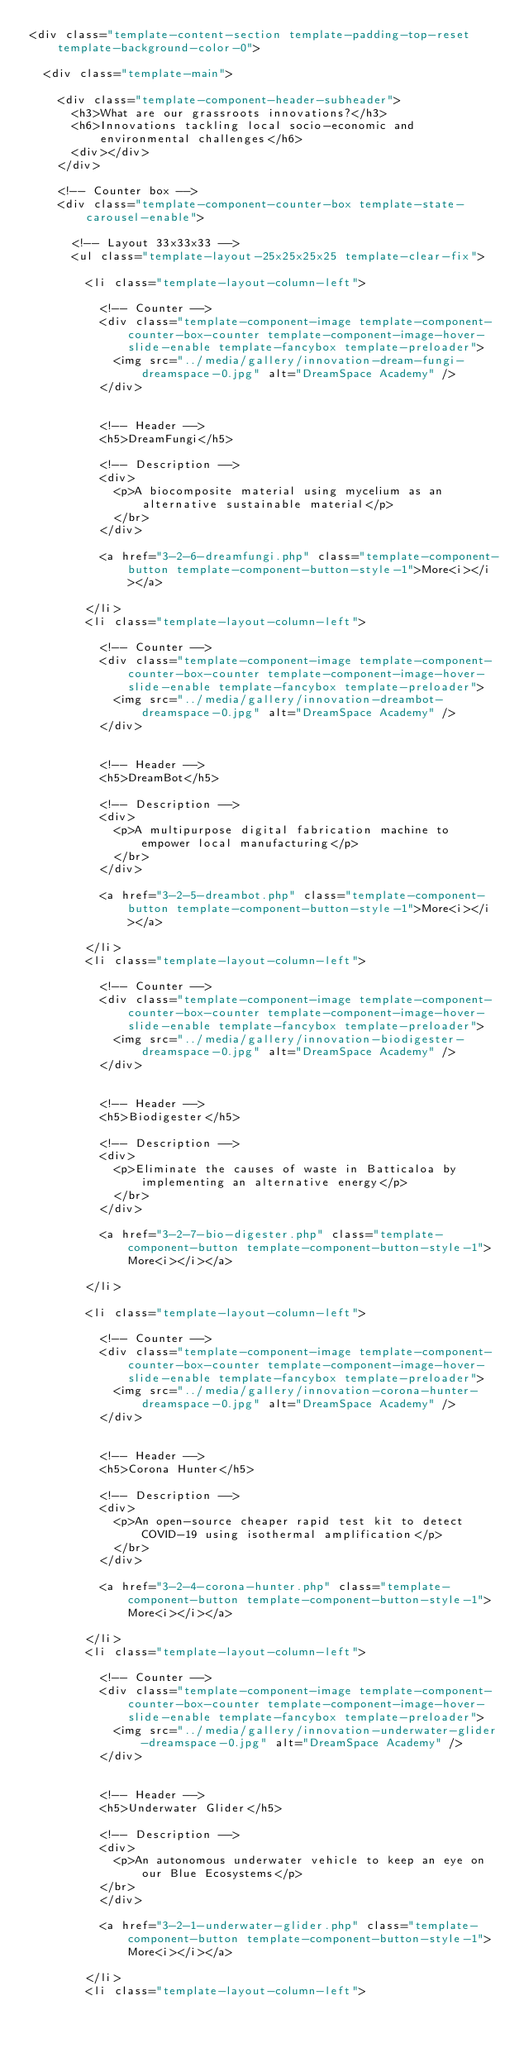Convert code to text. <code><loc_0><loc_0><loc_500><loc_500><_PHP_><div class="template-content-section template-padding-top-reset template-background-color-0">

	<div class="template-main">

		<div class="template-component-header-subheader">
			<h3>What are our grassroots innovations?</h3>
			<h6>Innovations tackling local socio-economic and environmental challenges</h6>
			<div></div>
		</div>

		<!-- Counter box -->
		<div class="template-component-counter-box template-state-carousel-enable">

			<!-- Layout 33x33x33 -->
			<ul class="template-layout-25x25x25x25 template-clear-fix">

				<li class="template-layout-column-left">

					<!-- Counter -->
					<div class="template-component-image template-component-counter-box-counter template-component-image-hover-slide-enable template-fancybox template-preloader">
						<img src="../media/gallery/innovation-dream-fungi-dreamspace-0.jpg" alt="DreamSpace Academy" />
					</div>


					<!-- Header -->
					<h5>DreamFungi</h5>

					<!-- Description -->
					<div>
						<p>A biocomposite material using mycelium as an alternative sustainable material</p>
						</br>
					</div>

					<a href="3-2-6-dreamfungi.php" class="template-component-button template-component-button-style-1">More<i></i></a>

				</li>
				<li class="template-layout-column-left">

					<!-- Counter -->
					<div class="template-component-image template-component-counter-box-counter template-component-image-hover-slide-enable template-fancybox template-preloader">
						<img src="../media/gallery/innovation-dreambot-dreamspace-0.jpg" alt="DreamSpace Academy" />
					</div>


					<!-- Header -->
					<h5>DreamBot</h5>

					<!-- Description -->
					<div>
						<p>A multipurpose digital fabrication machine to empower local manufacturing</p>
						</br>
					</div>

					<a href="3-2-5-dreambot.php" class="template-component-button template-component-button-style-1">More<i></i></a>

				</li>
				<li class="template-layout-column-left">

					<!-- Counter -->
					<div class="template-component-image template-component-counter-box-counter template-component-image-hover-slide-enable template-fancybox template-preloader">
						<img src="../media/gallery/innovation-biodigester-dreamspace-0.jpg" alt="DreamSpace Academy" />
					</div>


					<!-- Header -->
					<h5>Biodigester</h5>

					<!-- Description -->
					<div>
						<p>Eliminate the causes of waste in Batticaloa by implementing an alternative energy</p>
						</br>
					</div>

					<a href="3-2-7-bio-digester.php" class="template-component-button template-component-button-style-1">More<i></i></a>

				</li>

				<li class="template-layout-column-left">

					<!-- Counter -->
					<div class="template-component-image template-component-counter-box-counter template-component-image-hover-slide-enable template-fancybox template-preloader">
						<img src="../media/gallery/innovation-corona-hunter-dreamspace-0.jpg" alt="DreamSpace Academy" />
					</div>


					<!-- Header -->
					<h5>Corona Hunter</h5>

					<!-- Description -->
					<div>
						<p>An open-source cheaper rapid test kit to detect COVID-19 using isothermal amplification</p>
						</br>
					</div>

					<a href="3-2-4-corona-hunter.php" class="template-component-button template-component-button-style-1">More<i></i></a>

				</li>
				<li class="template-layout-column-left">

					<!-- Counter -->
					<div class="template-component-image template-component-counter-box-counter template-component-image-hover-slide-enable template-fancybox template-preloader">
						<img src="../media/gallery/innovation-underwater-glider-dreamspace-0.jpg" alt="DreamSpace Academy" />
					</div>


					<!-- Header -->
					<h5>Underwater Glider</h5>

					<!-- Description -->
					<div>
						<p>An autonomous underwater vehicle to keep an eye on our Blue Ecosystems</p>
					</br>
					</div>

					<a href="3-2-1-underwater-glider.php" class="template-component-button template-component-button-style-1">More<i></i></a>

				</li>
				<li class="template-layout-column-left">
</code> 